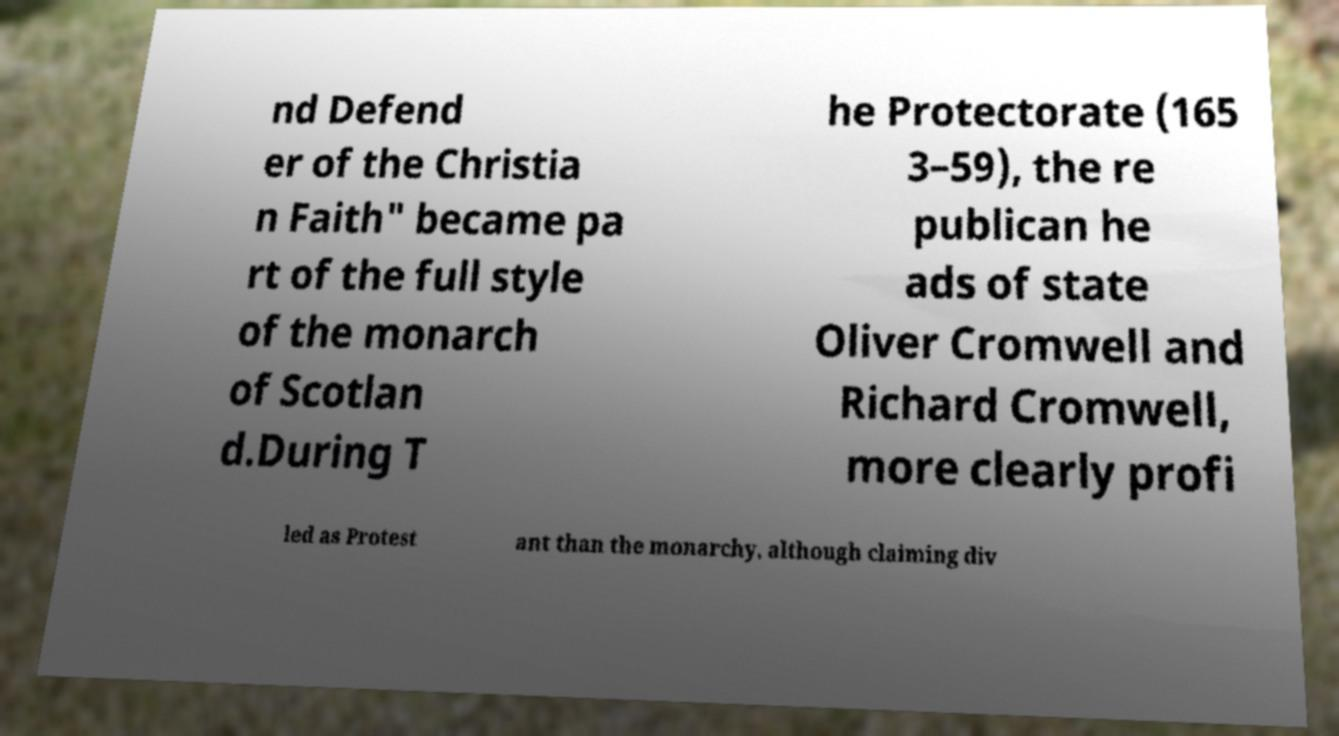There's text embedded in this image that I need extracted. Can you transcribe it verbatim? nd Defend er of the Christia n Faith" became pa rt of the full style of the monarch of Scotlan d.During T he Protectorate (165 3–59), the re publican he ads of state Oliver Cromwell and Richard Cromwell, more clearly profi led as Protest ant than the monarchy, although claiming div 